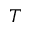Convert formula to latex. <formula><loc_0><loc_0><loc_500><loc_500>T</formula> 